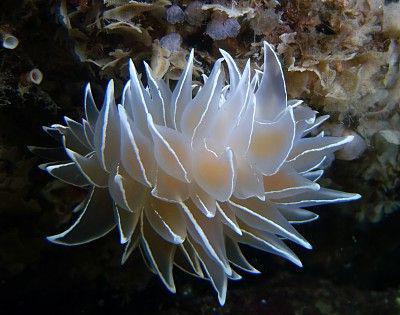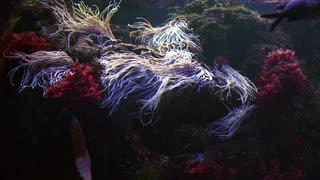The first image is the image on the left, the second image is the image on the right. For the images displayed, is the sentence "Right image features an anemone with stringy whitish tendrils, and the left image includes a pale white anemone." factually correct? Answer yes or no. Yes. The first image is the image on the left, the second image is the image on the right. Assess this claim about the two images: "There are at least two clown fish.". Correct or not? Answer yes or no. No. 